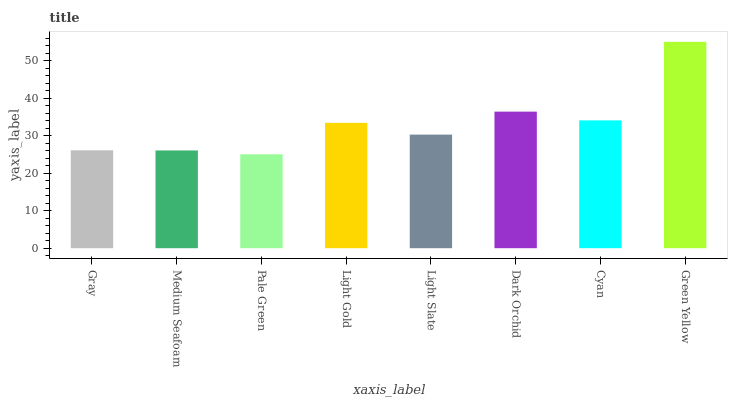Is Pale Green the minimum?
Answer yes or no. Yes. Is Green Yellow the maximum?
Answer yes or no. Yes. Is Medium Seafoam the minimum?
Answer yes or no. No. Is Medium Seafoam the maximum?
Answer yes or no. No. Is Gray greater than Medium Seafoam?
Answer yes or no. Yes. Is Medium Seafoam less than Gray?
Answer yes or no. Yes. Is Medium Seafoam greater than Gray?
Answer yes or no. No. Is Gray less than Medium Seafoam?
Answer yes or no. No. Is Light Gold the high median?
Answer yes or no. Yes. Is Light Slate the low median?
Answer yes or no. Yes. Is Cyan the high median?
Answer yes or no. No. Is Cyan the low median?
Answer yes or no. No. 